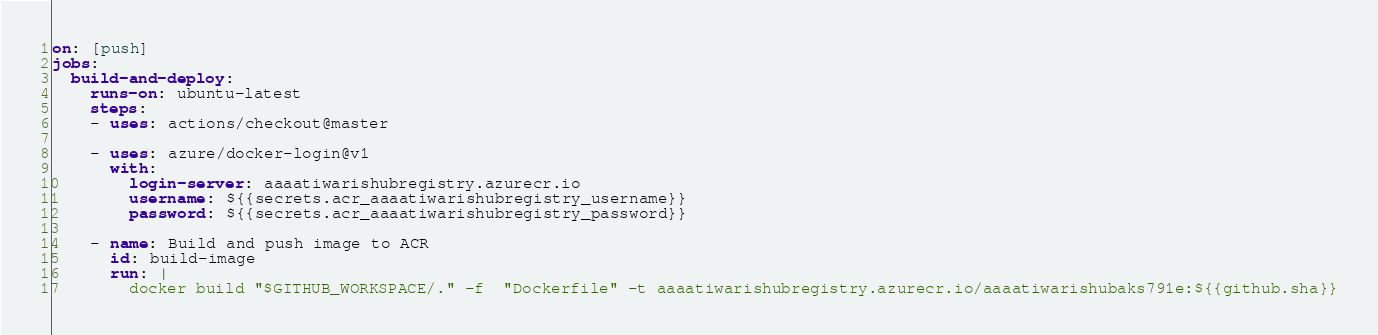Convert code to text. <code><loc_0><loc_0><loc_500><loc_500><_YAML_>on: [push]
jobs:
  build-and-deploy:
    runs-on: ubuntu-latest
    steps:
    - uses: actions/checkout@master
    
    - uses: azure/docker-login@v1
      with:
        login-server: aaaatiwarishubregistry.azurecr.io
        username: ${{secrets.acr_aaaatiwarishubregistry_username}}
        password: ${{secrets.acr_aaaatiwarishubregistry_password}}
    
    - name: Build and push image to ACR
      id: build-image
      run: |
        docker build "$GITHUB_WORKSPACE/." -f  "Dockerfile" -t aaaatiwarishubregistry.azurecr.io/aaaatiwarishubaks791e:${{github.sha}}</code> 